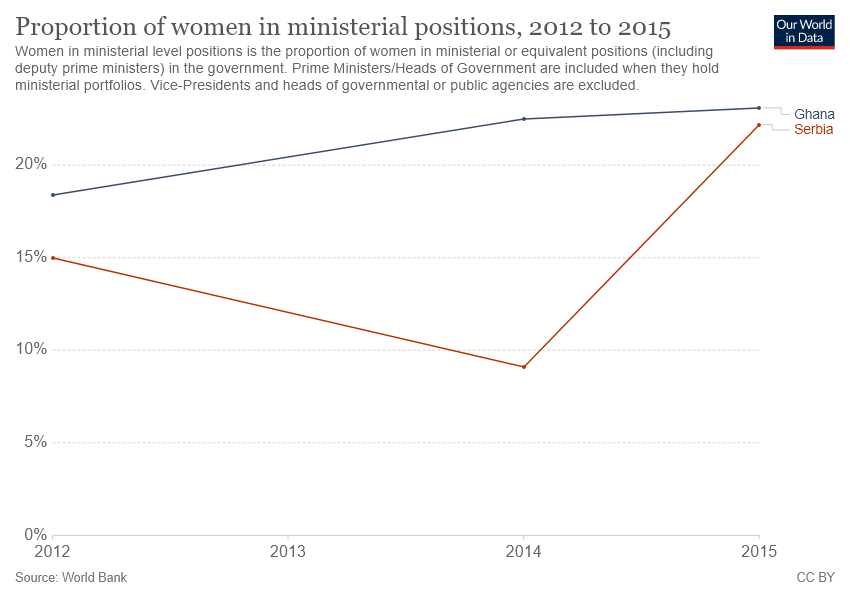Highlight a few significant elements in this photo. In 2014, the proportion of women in ministerial positions was lowest in Serbia. In 2014, the proportion of women in ministerial positions in Ghana was higher than 20%. 